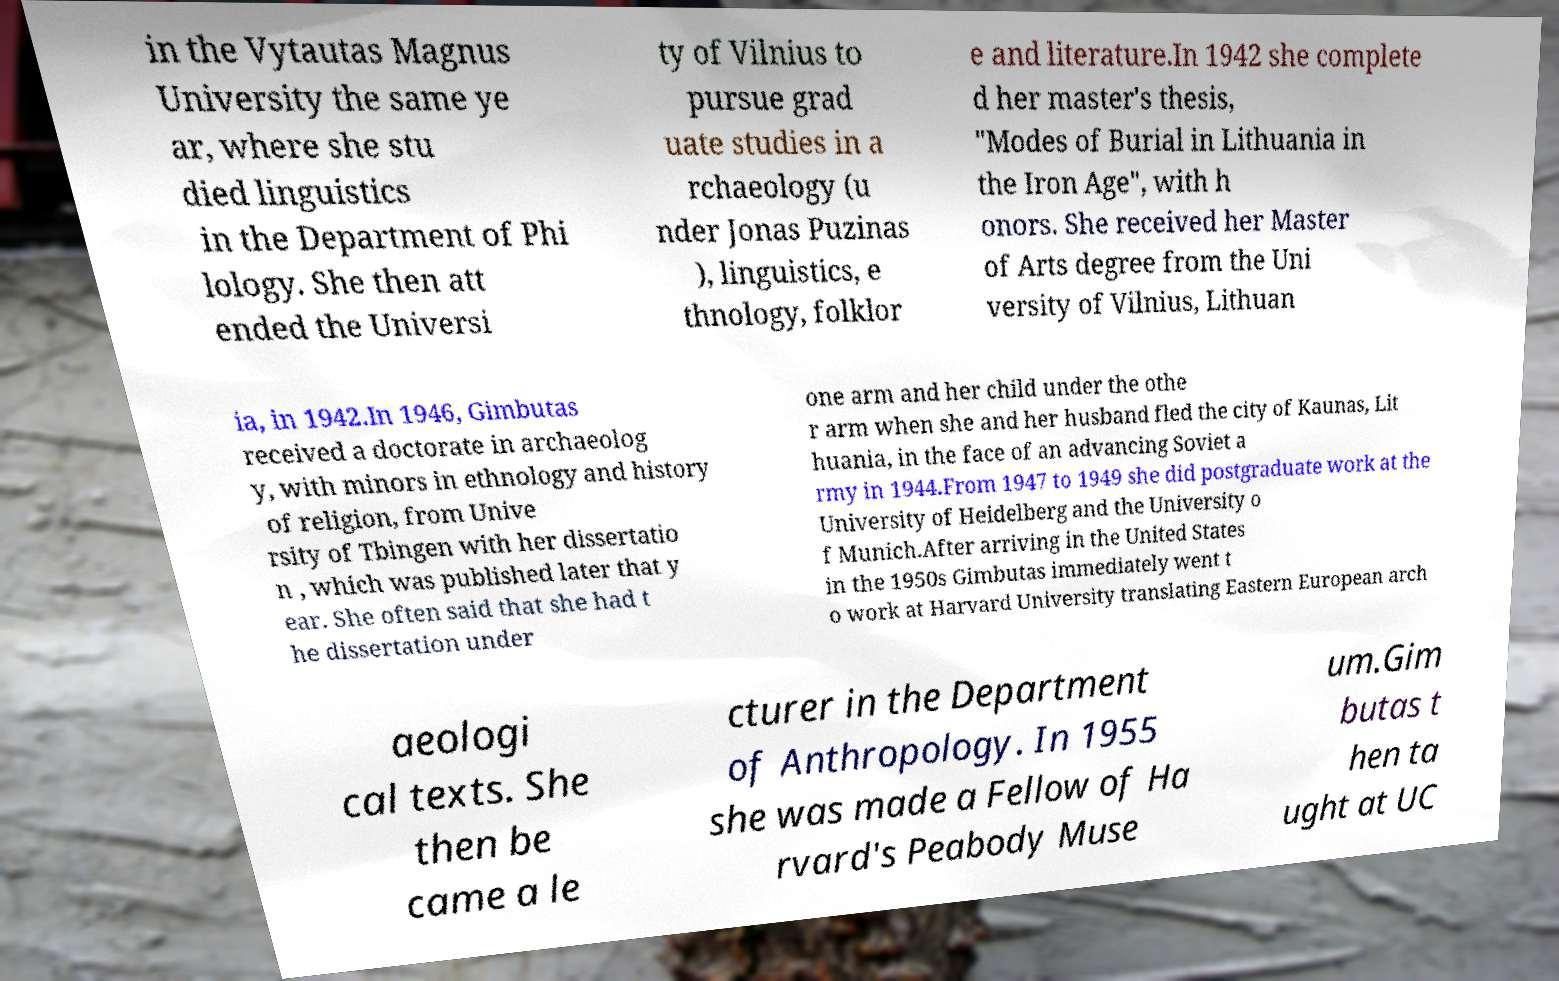Could you extract and type out the text from this image? in the Vytautas Magnus University the same ye ar, where she stu died linguistics in the Department of Phi lology. She then att ended the Universi ty of Vilnius to pursue grad uate studies in a rchaeology (u nder Jonas Puzinas ), linguistics, e thnology, folklor e and literature.In 1942 she complete d her master's thesis, "Modes of Burial in Lithuania in the Iron Age", with h onors. She received her Master of Arts degree from the Uni versity of Vilnius, Lithuan ia, in 1942.In 1946, Gimbutas received a doctorate in archaeolog y, with minors in ethnology and history of religion, from Unive rsity of Tbingen with her dissertatio n , which was published later that y ear. She often said that she had t he dissertation under one arm and her child under the othe r arm when she and her husband fled the city of Kaunas, Lit huania, in the face of an advancing Soviet a rmy in 1944.From 1947 to 1949 she did postgraduate work at the University of Heidelberg and the University o f Munich.After arriving in the United States in the 1950s Gimbutas immediately went t o work at Harvard University translating Eastern European arch aeologi cal texts. She then be came a le cturer in the Department of Anthropology. In 1955 she was made a Fellow of Ha rvard's Peabody Muse um.Gim butas t hen ta ught at UC 